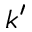<formula> <loc_0><loc_0><loc_500><loc_500>k ^ { \prime }</formula> 